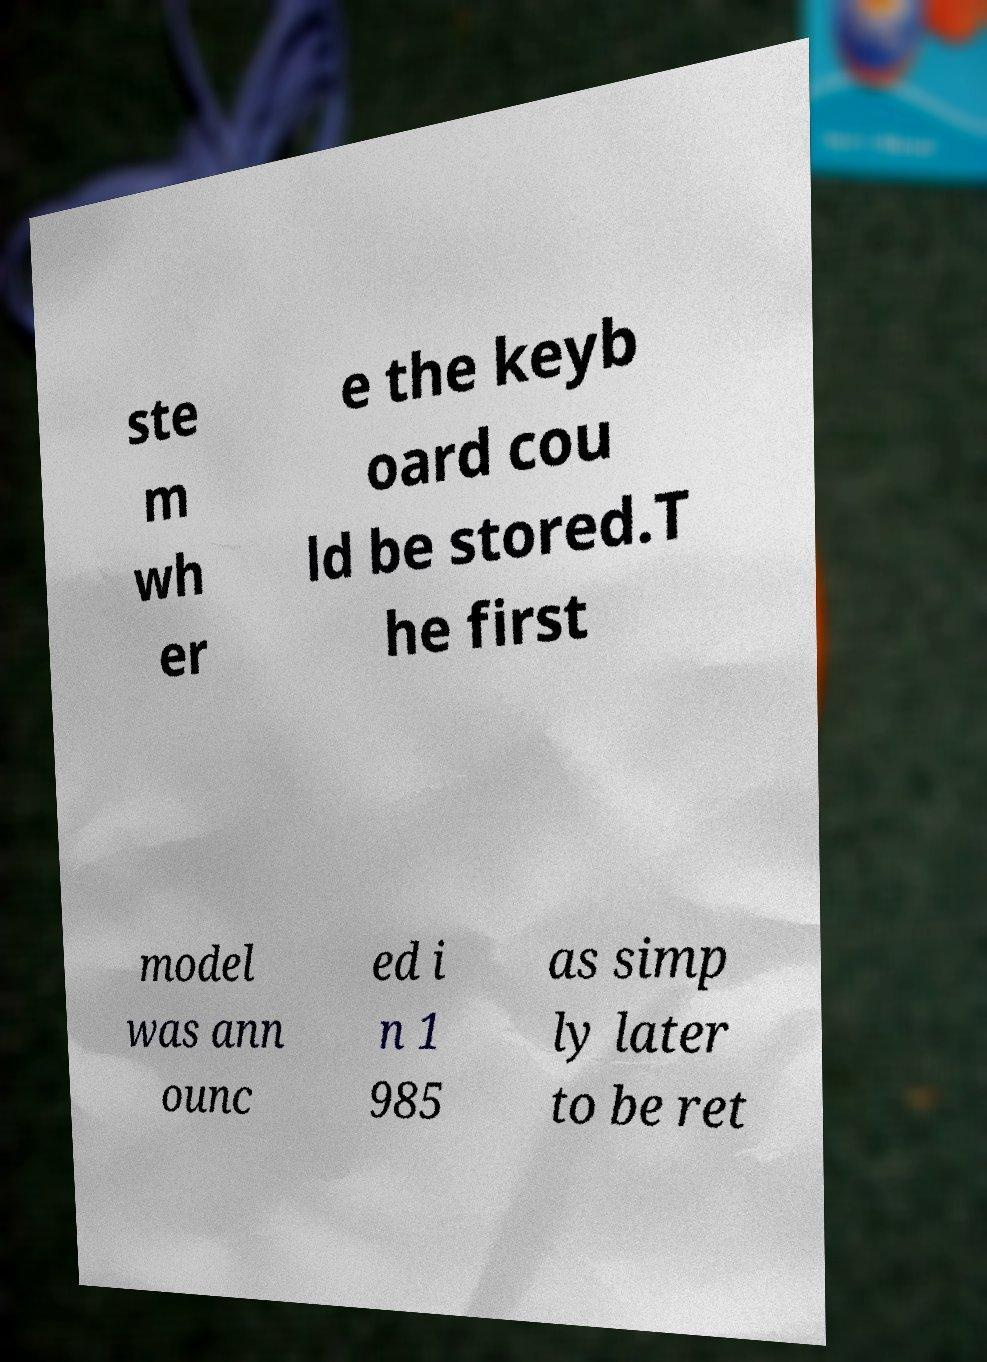Can you read and provide the text displayed in the image?This photo seems to have some interesting text. Can you extract and type it out for me? ste m wh er e the keyb oard cou ld be stored.T he first model was ann ounc ed i n 1 985 as simp ly later to be ret 